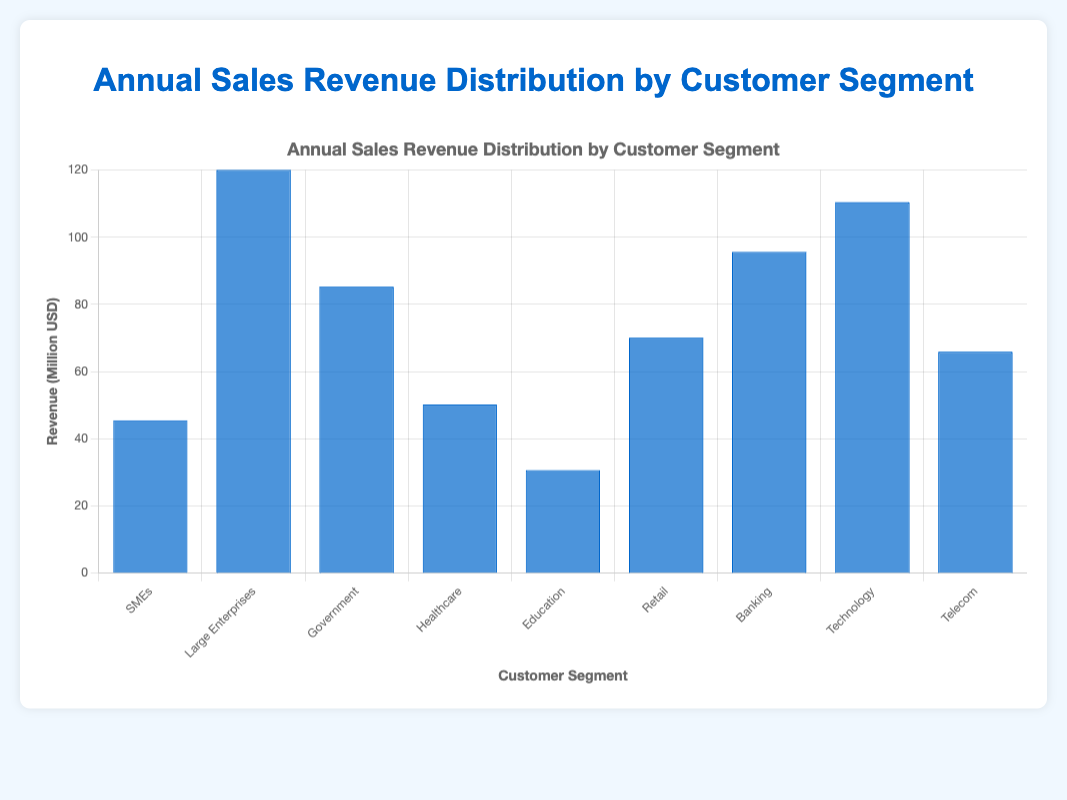Which customer segment generates the highest annual sales revenue? The bar with the greatest height corresponds to "Large Enterprises," indicating it generates the highest revenue of 120 million USD.
Answer: Large Enterprises Which customer segment generates the lowest annual sales revenue? The shortest bar corresponds to the "Education" segment, indicating it generates the lowest revenue of 30.7 million USD.
Answer: Education How much more revenue does the Banking segment generate compared to the Healthcare segment? The revenue for Banking is 95.6 million USD and for Healthcare is 50.2 million USD. Subtracting Healthcare's revenue from Banking's revenue: 95.6 - 50.2 = 45.4 million USD.
Answer: 45.4 million USD What is the total annual sales revenue generated by the Government and Technology segments combined? The Government segment generates 85.3 million USD and the Technology segment generates 110.4 million USD. Adding these values: 85.3 + 110.4 = 195.7 million USD.
Answer: 195.7 million USD Which customer segments generate more than 70 million USD in annual sales revenue? The bars exceeding the 70 million USD mark correspond to Large Enterprises, Government, Banking, and Technology segments.
Answer: Large Enterprises, Government, Banking, Technology Which customer segment generates approximately half the revenue of Large Enterprises? The revenue for Large Enterprises is 120 million USD. Half of this amount is 60 million USD. The Telecom segment generates 65.9 million USD, which is closest to half the Large Enterprises’ revenue.
Answer: Telecom What is the average annual sales revenue across all customer segments? Summing the revenues: 45.5 (SMEs) + 120.0 (Large Enterprises) + 85.3 (Government) + 50.2 (Healthcare) + 30.7 (Education) + 70.1 (Retail) + 95.6 (Banking) + 110.4 (Technology) + 65.9 (Telecom) = 673.7 million USD. Dividing by the number of segments (9): 673.7 / 9 = 74.9 million USD.
Answer: 74.9 million USD How much more revenue does the Technology segment generate than the SMEs segment? The Technology segment generates 110.4 million USD, and the SMEs segment generates 45.5 million USD. Subtracting SMEs from Technology: 110.4 - 45.5 = 64.9 million USD.
Answer: 64.9 million USD How much total revenue is generated by the Retail and Telecom segments? The Retail segment generates 70.1 million USD and the Telecom segment generates 65.9 million USD. Adding these values: 70.1 + 65.9 = 136 million USD.
Answer: 136 million USD 